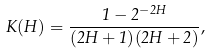<formula> <loc_0><loc_0><loc_500><loc_500>K ( H ) = \frac { 1 - 2 ^ { - 2 H } } { ( 2 H + 1 ) ( 2 H + 2 ) } ,</formula> 